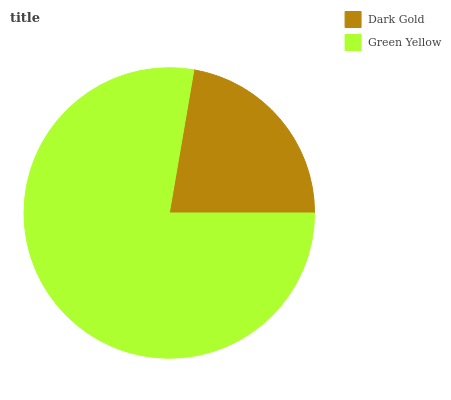Is Dark Gold the minimum?
Answer yes or no. Yes. Is Green Yellow the maximum?
Answer yes or no. Yes. Is Green Yellow the minimum?
Answer yes or no. No. Is Green Yellow greater than Dark Gold?
Answer yes or no. Yes. Is Dark Gold less than Green Yellow?
Answer yes or no. Yes. Is Dark Gold greater than Green Yellow?
Answer yes or no. No. Is Green Yellow less than Dark Gold?
Answer yes or no. No. Is Green Yellow the high median?
Answer yes or no. Yes. Is Dark Gold the low median?
Answer yes or no. Yes. Is Dark Gold the high median?
Answer yes or no. No. Is Green Yellow the low median?
Answer yes or no. No. 